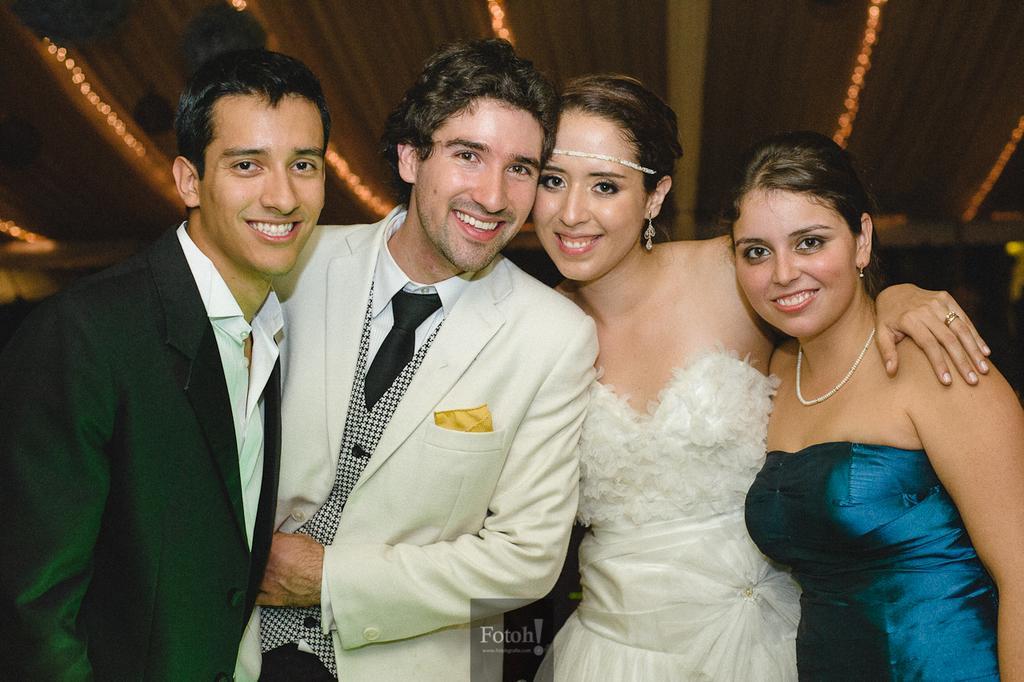In one or two sentences, can you explain what this image depicts? In the middle of the image few people are standing and smiling. Behind them there is a wall. 